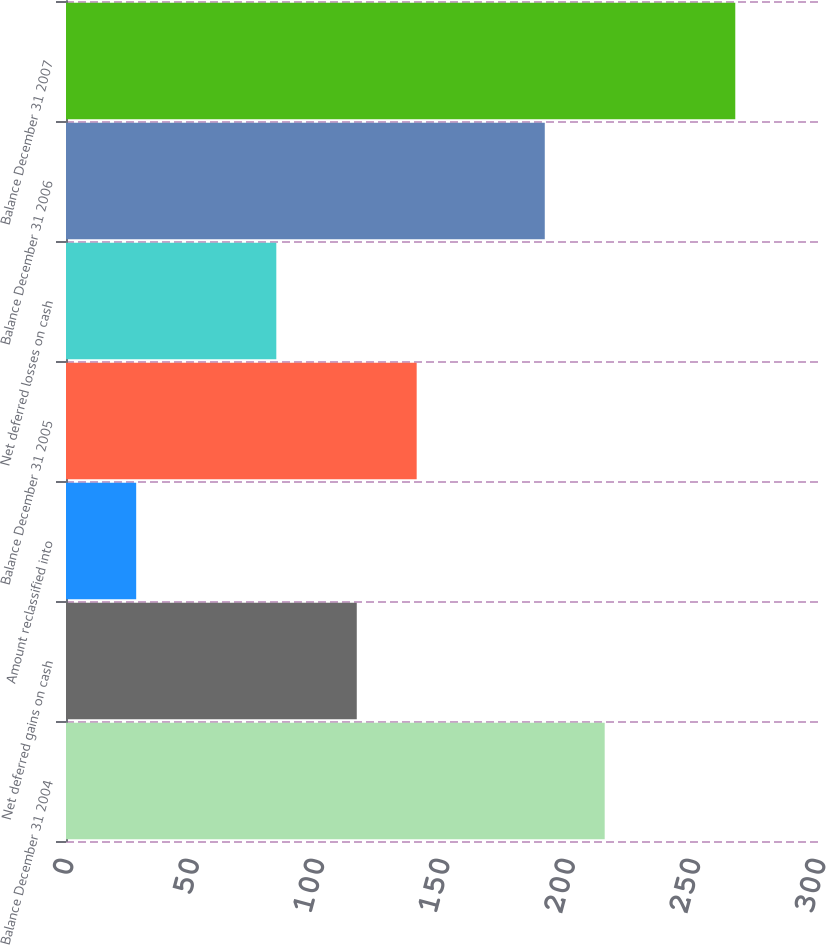Convert chart to OTSL. <chart><loc_0><loc_0><loc_500><loc_500><bar_chart><fcel>Balance December 31 2004<fcel>Net deferred gains on cash<fcel>Amount reclassified into<fcel>Balance December 31 2005<fcel>Net deferred losses on cash<fcel>Balance December 31 2006<fcel>Balance December 31 2007<nl><fcel>214.9<fcel>116<fcel>28<fcel>139.9<fcel>83.9<fcel>191<fcel>267<nl></chart> 